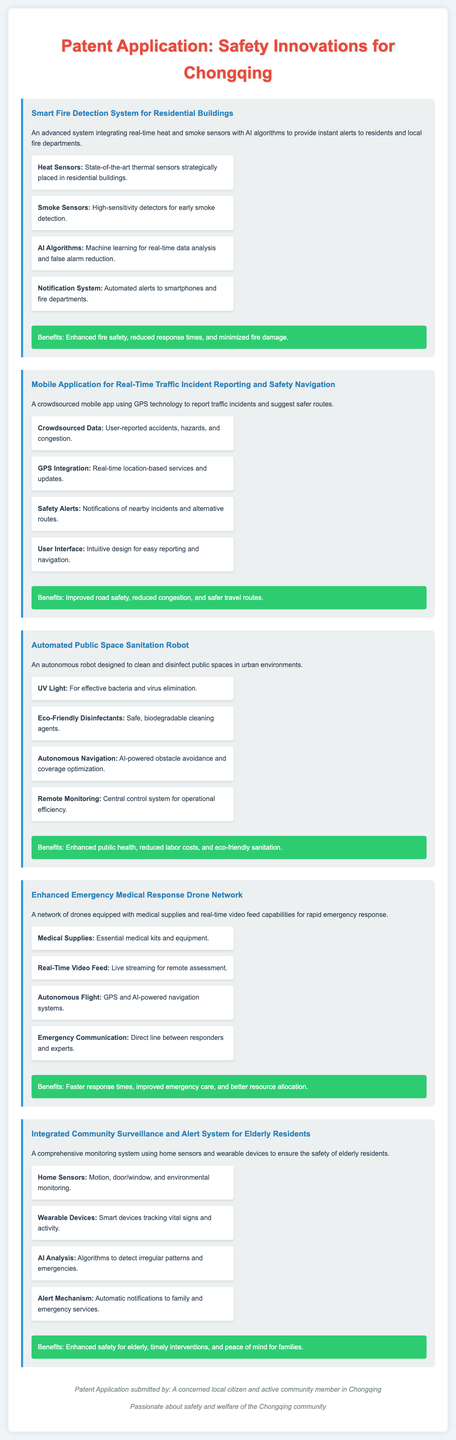what is the main focus of the patent application? The main focus of the patent application is on safety innovations for the Chongqing community.
Answer: safety innovations for Chongqing how many innovations are described in the document? The document describes five different safety innovations.
Answer: five what technology does the Smart Fire Detection System integrate? The Smart Fire Detection System integrates real-time heat and smoke sensors with AI algorithms.
Answer: heat and smoke sensors with AI algorithms what feature alerts family members in the Integrated Community Surveillance and Alert System? The alert mechanism in the Integrated Community Surveillance and Alert System automatically notifies family members.
Answer: automatic notifications what is the purpose of the Automated Public Space Sanitation Robot? The purpose of the Automated Public Space Sanitation Robot is to clean and sanitize public areas.
Answer: clean and sanitize public areas which innovation includes GPS technology? The Mobile Application for Real-Time Traffic Incident Reporting and Safety Navigation includes GPS technology.
Answer: Mobile Application for Real-Time Traffic Incident Reporting and Safety Navigation what benefit does the Enhanced Emergency Medical Response Drone Network provide? The Enhanced Emergency Medical Response Drone Network provides faster response times.
Answer: faster response times what kind of disinfectants does the Automated Public Space Sanitation Robot use? The robot uses eco-friendly disinfectants for cleaning.
Answer: eco-friendly disinfectants what are critical components of the Enhanced Emergency Medical Response Drone Network? Critical components include medical supplies and real-time video feed.
Answer: medical supplies and real-time video feed 